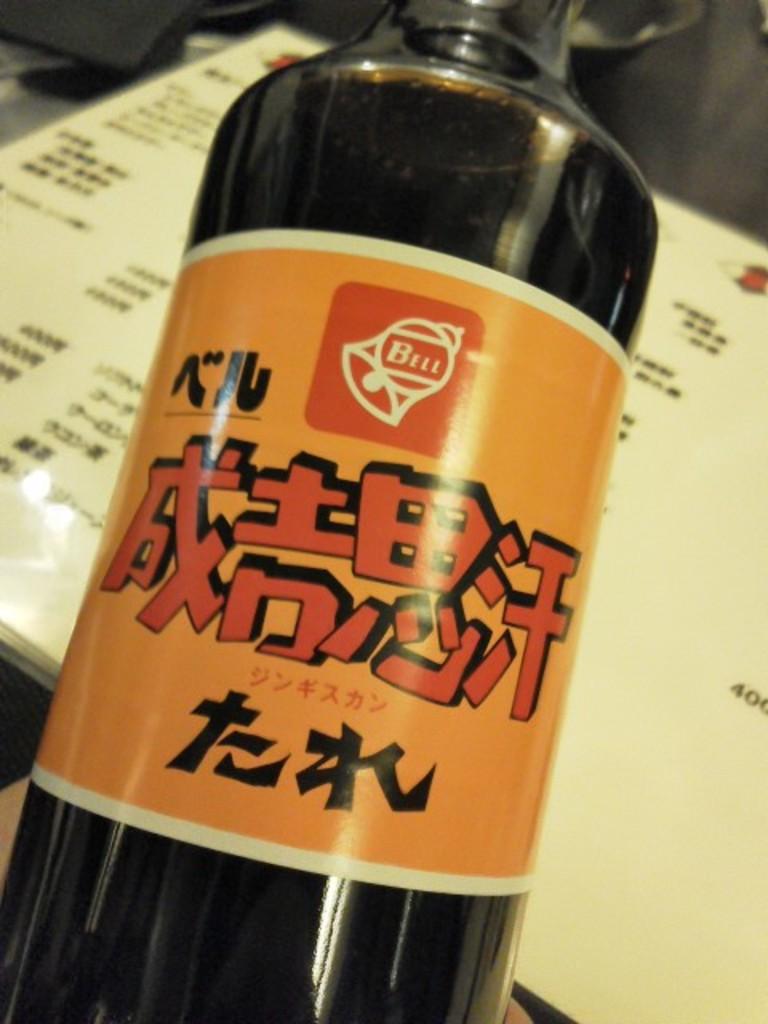What is written on the symbol in the orange square?
Your answer should be very brief. Bell. Is this in a foreign language?
Your answer should be very brief. Yes. 